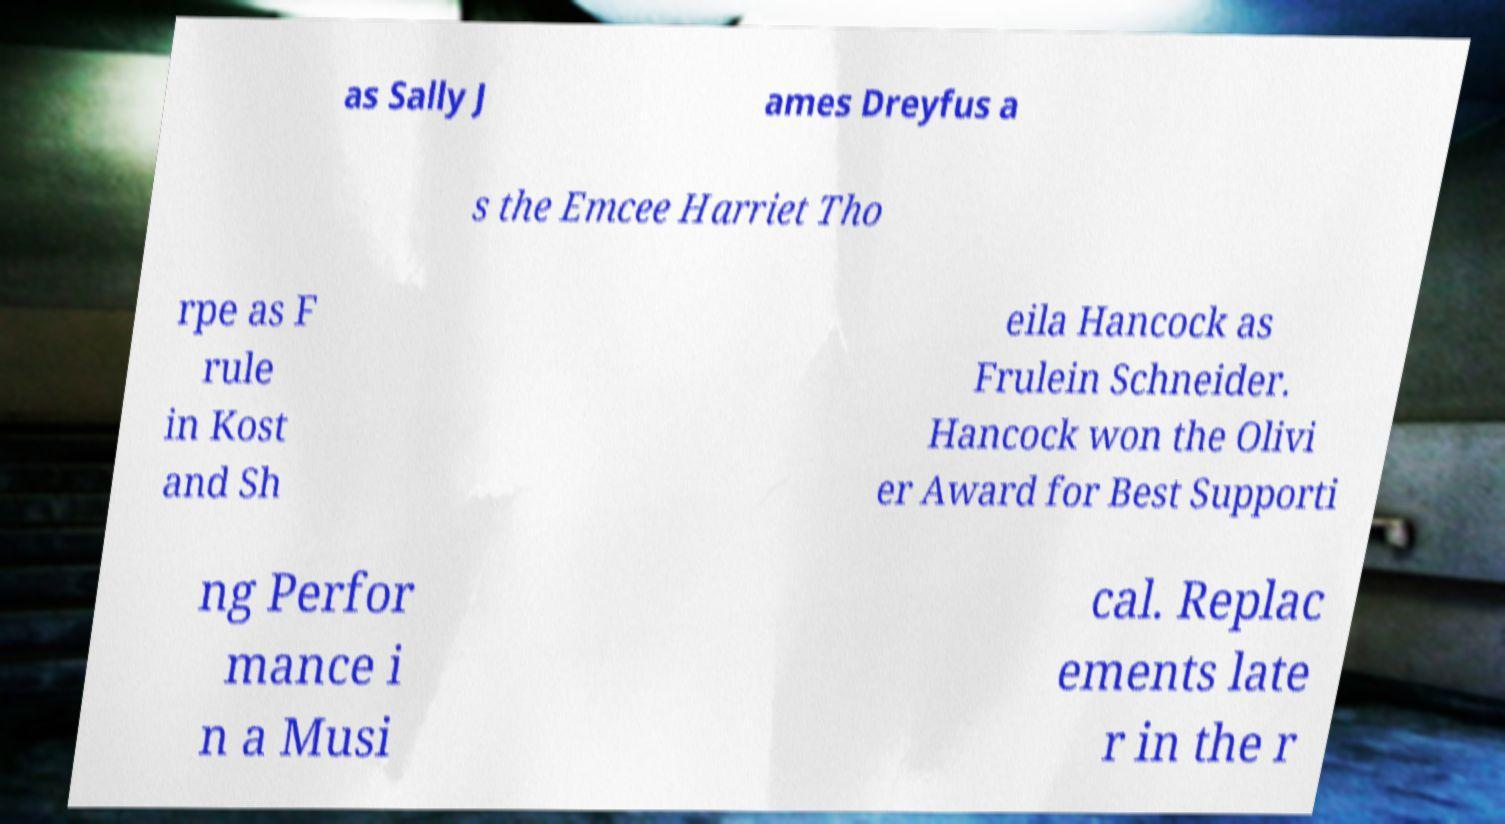Could you extract and type out the text from this image? as Sally J ames Dreyfus a s the Emcee Harriet Tho rpe as F rule in Kost and Sh eila Hancock as Frulein Schneider. Hancock won the Olivi er Award for Best Supporti ng Perfor mance i n a Musi cal. Replac ements late r in the r 